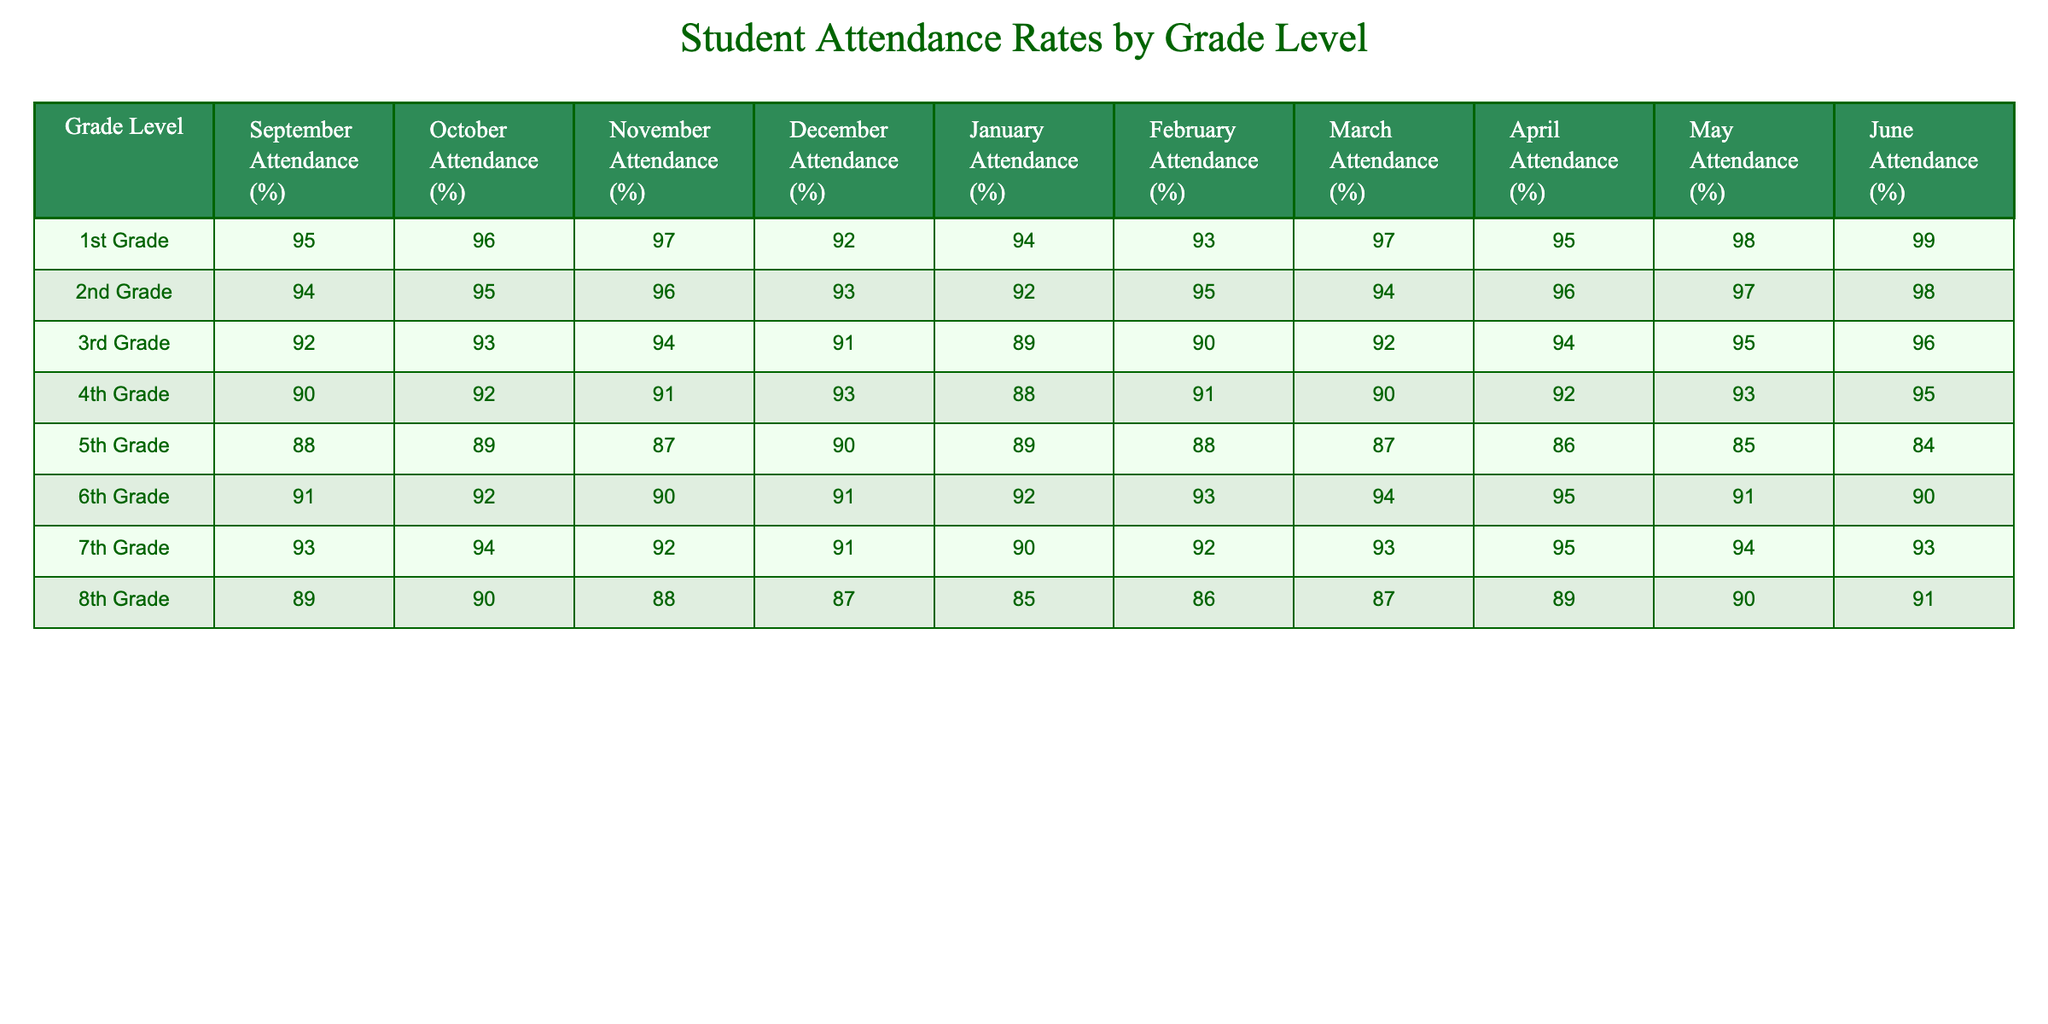What is the attendance rate for 1st Grade in May? Looking at the row for 1st Grade, the attendance rate for May is listed directly under the May column. It shows a value of 98%.
Answer: 98% Which grade level had the highest attendance rate in April? By comparing the values in the April column for all grade levels, 6th Grade shows the highest attendance at 95%.
Answer: 6th Grade What was the average attendance rate for 5th Grade across the school year? To find the average, sum the attendance rates for each month (88 + 89 + 87 + 90 + 89 + 88 + 87 + 86 + 85 + 84) = 878. Then divide by 10 months, so 878 ÷ 10 = 87.8.
Answer: 87.8 Did 4th Grade's attendance rate in February exceed 90%? Referring to the February column for 4th Grade shows a value of 91%, which is greater than 90%.
Answer: Yes Which grade showed the least improvement in attendance from September to June? To find this, calculate the difference between September and June attendance for each grade. The calculations reveal that for 5th Grade, it dropped from 88% in September to 84% in June, which is a decrease of 4%.
Answer: 5th Grade In which month did 3rd Grade have its lowest attendance rate? Reviewing the attendance rates for 3rd Grade, the lowest value is found in January at 89%.
Answer: January Is it true that 2nd Grade consistently had higher attendance rates than 3rd Grade throughout the school year? Comparing the attendance rates month by month shows that 2nd Grade outperformed 3rd Grade every month in the given data.
Answer: Yes What was the percentage increase in attendance for 7th Grade from September to June? The attendance rate for 7th Grade increased from 93% in September to 93% in June, indicating no change. Therefore, the increase is 0%.
Answer: 0% 